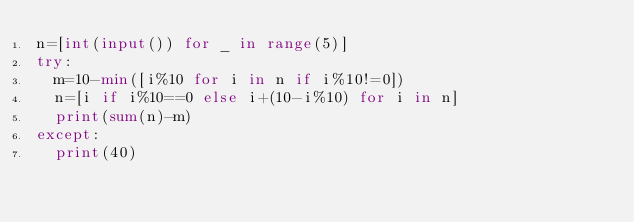<code> <loc_0><loc_0><loc_500><loc_500><_Python_>n=[int(input()) for _ in range(5)]
try:
  m=10-min([i%10 for i in n if i%10!=0])
  n=[i if i%10==0 else i+(10-i%10) for i in n]
  print(sum(n)-m)
except:
  print(40)</code> 